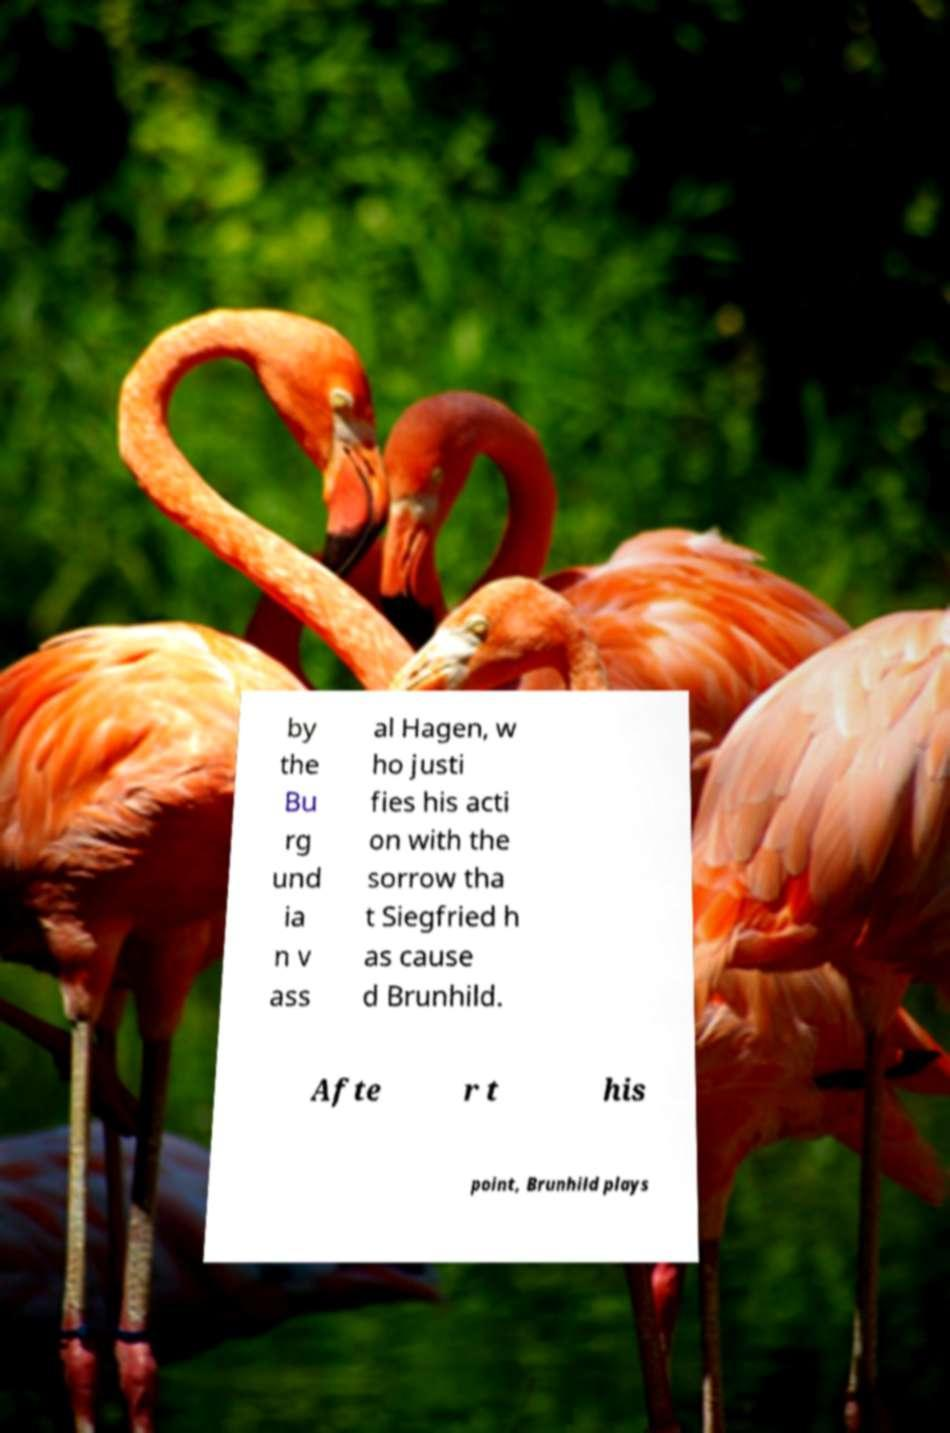Can you accurately transcribe the text from the provided image for me? by the Bu rg und ia n v ass al Hagen, w ho justi fies his acti on with the sorrow tha t Siegfried h as cause d Brunhild. Afte r t his point, Brunhild plays 